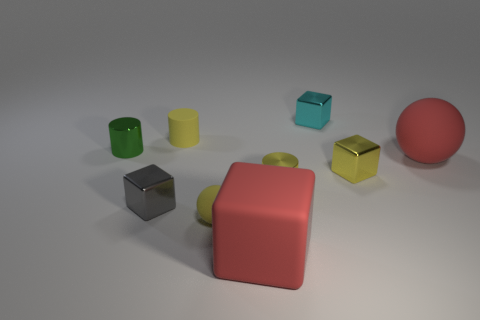There is a matte object that is behind the green thing; is its shape the same as the yellow rubber object that is in front of the large matte sphere?
Your answer should be very brief. No. There is a large object that is the same color as the matte block; what is its shape?
Provide a short and direct response. Sphere. Is there a small yellow block made of the same material as the gray object?
Keep it short and to the point. Yes. How many matte things are either small gray cylinders or small gray blocks?
Offer a terse response. 0. What shape is the small yellow rubber thing in front of the yellow object behind the yellow block?
Your answer should be very brief. Sphere. Is the number of yellow spheres to the left of the tiny cyan metal thing less than the number of big objects?
Your answer should be compact. Yes. What is the shape of the small gray shiny object?
Ensure brevity in your answer.  Cube. What size is the rubber ball that is behind the tiny gray metal block?
Give a very brief answer. Large. There is a matte sphere that is the same size as the yellow metallic block; what is its color?
Provide a succinct answer. Yellow. Is there a small rubber object that has the same color as the matte block?
Ensure brevity in your answer.  No. 